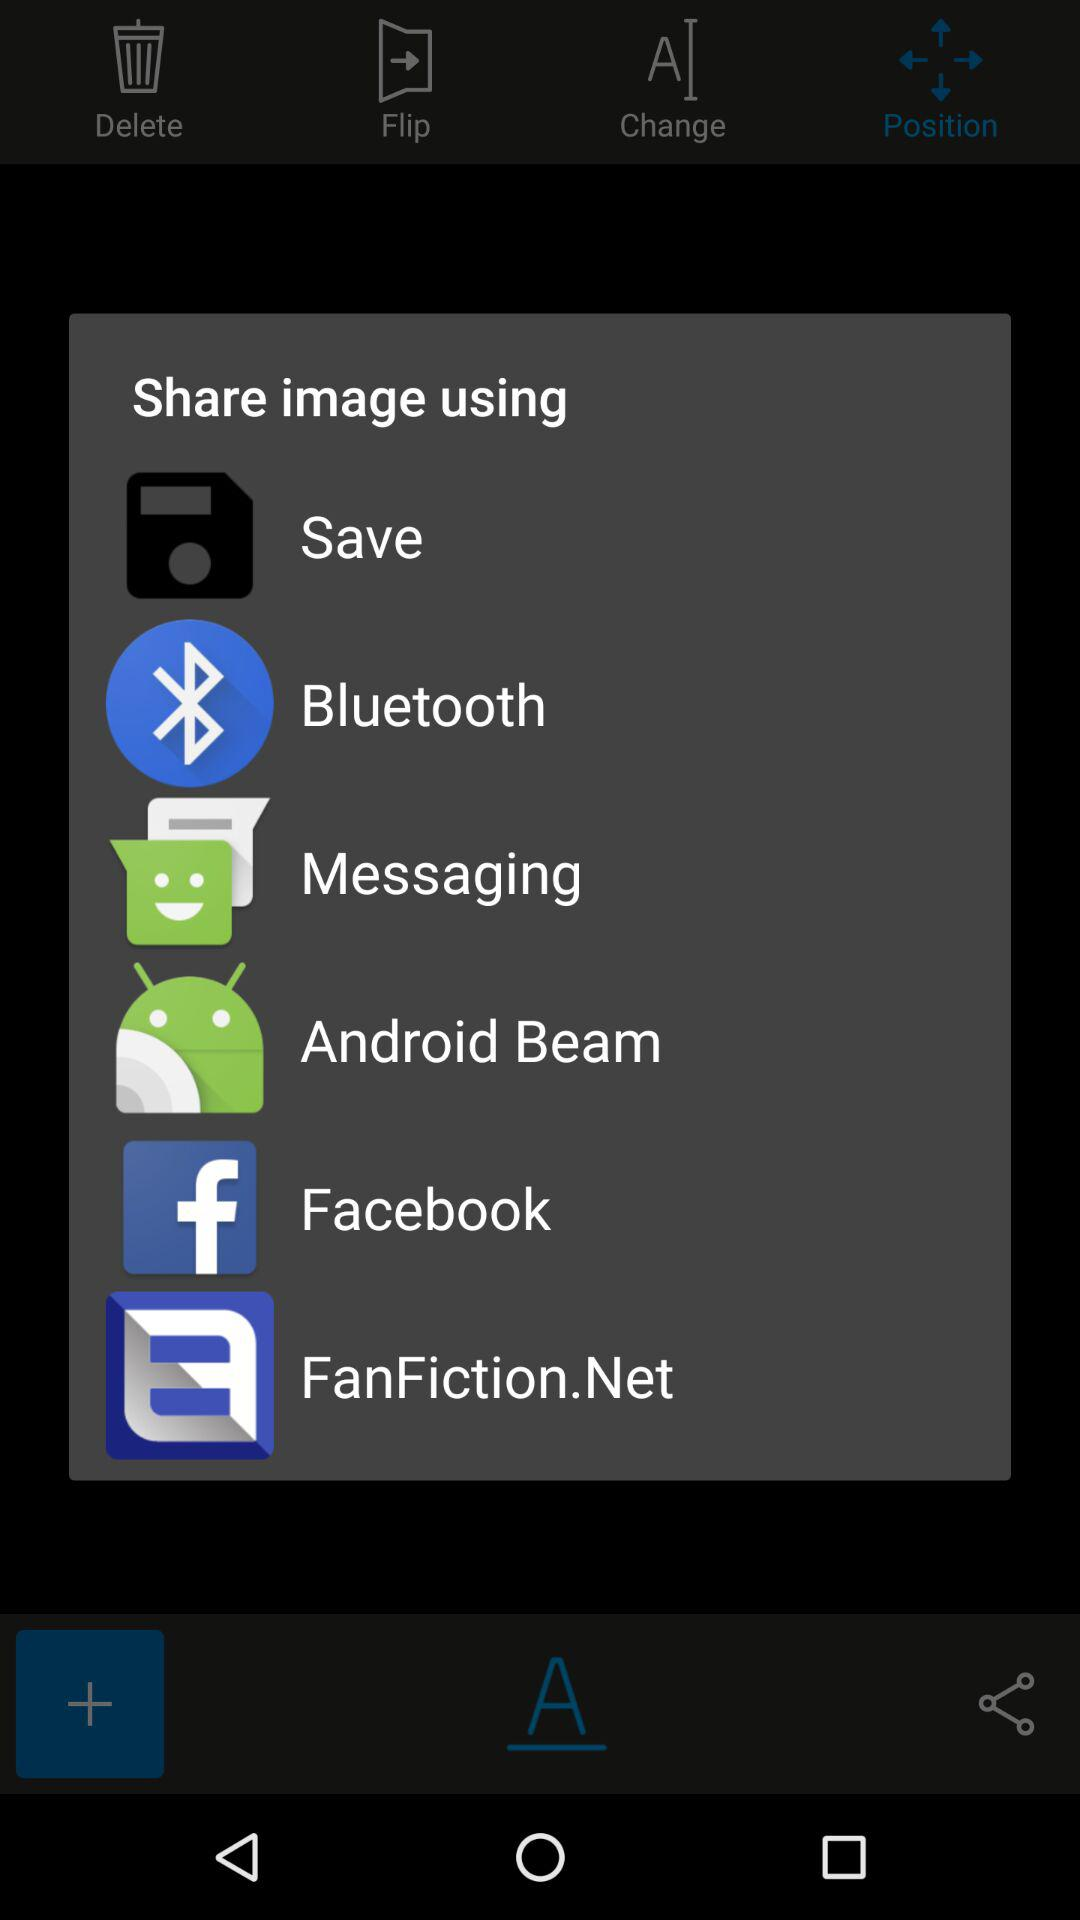What are the sharing options? The sharing options are "Save", "Bluetooth", "Messaging", "Android Beam", "Facebook" and "FanFiction.Net". 